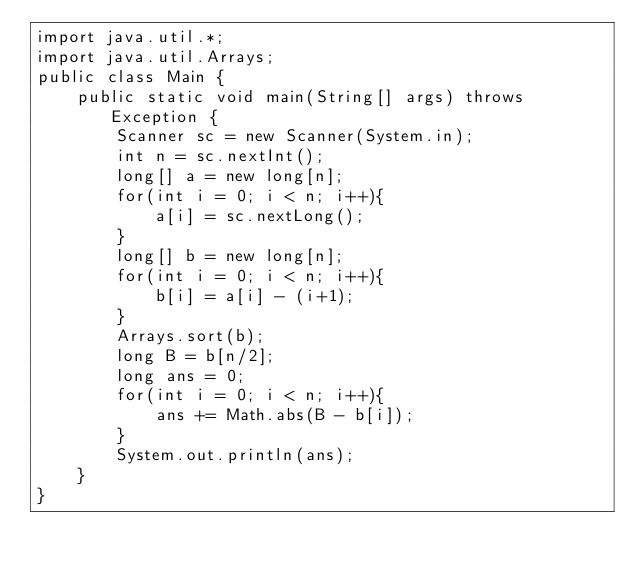<code> <loc_0><loc_0><loc_500><loc_500><_Java_>import java.util.*;
import java.util.Arrays;
public class Main {
    public static void main(String[] args) throws Exception {
        Scanner sc = new Scanner(System.in);
        int n = sc.nextInt();
        long[] a = new long[n];
        for(int i = 0; i < n; i++){
            a[i] = sc.nextLong();
        }
        long[] b = new long[n];
        for(int i = 0; i < n; i++){
            b[i] = a[i] - (i+1);
        }
        Arrays.sort(b);
        long B = b[n/2];
        long ans = 0;
        for(int i = 0; i < n; i++){
            ans += Math.abs(B - b[i]);
        }
        System.out.println(ans);
    }
}
</code> 